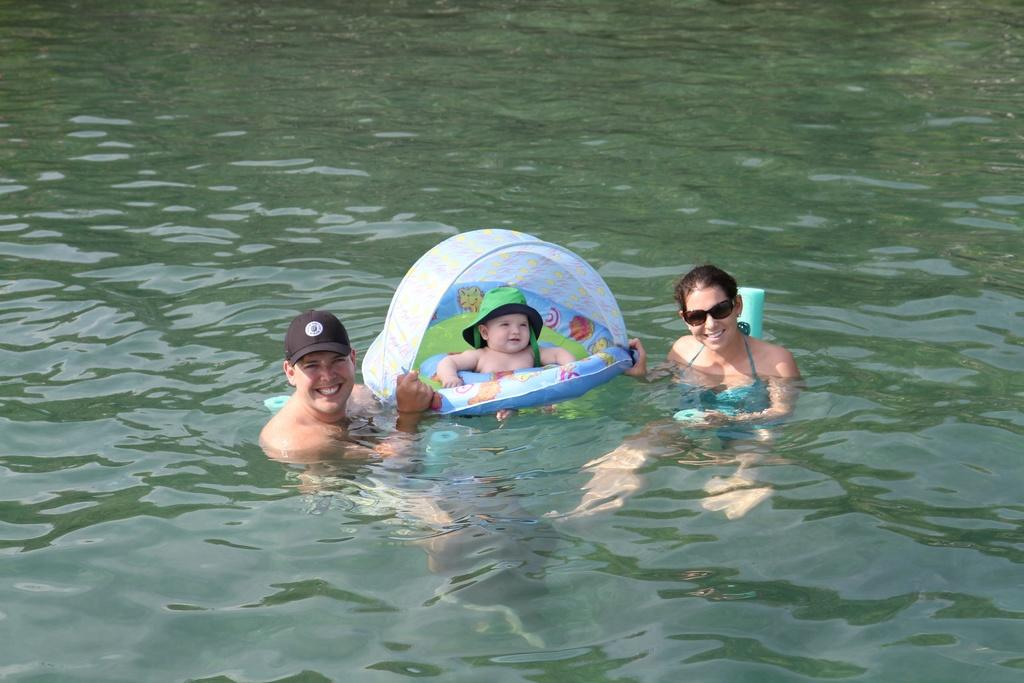How many people are in the water in the image? There are three persons in the water. Can you describe the youngest person in the water? There is a baby in the water. How is the baby protected in the water? The baby is inside a swimming tube. What type of cable can be seen connecting the baby to the cat in the image? There is no cable or cat present in the image; it features three persons in the water, including a baby inside a swimming tube. 